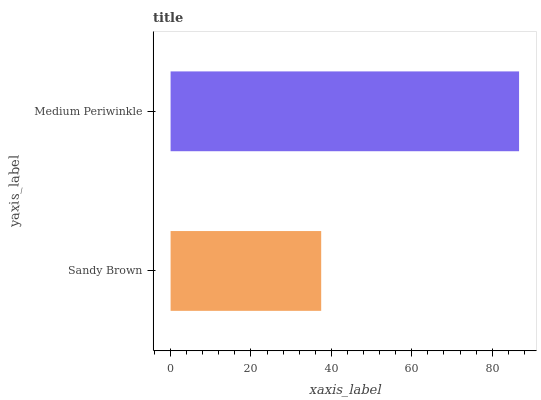Is Sandy Brown the minimum?
Answer yes or no. Yes. Is Medium Periwinkle the maximum?
Answer yes or no. Yes. Is Medium Periwinkle the minimum?
Answer yes or no. No. Is Medium Periwinkle greater than Sandy Brown?
Answer yes or no. Yes. Is Sandy Brown less than Medium Periwinkle?
Answer yes or no. Yes. Is Sandy Brown greater than Medium Periwinkle?
Answer yes or no. No. Is Medium Periwinkle less than Sandy Brown?
Answer yes or no. No. Is Medium Periwinkle the high median?
Answer yes or no. Yes. Is Sandy Brown the low median?
Answer yes or no. Yes. Is Sandy Brown the high median?
Answer yes or no. No. Is Medium Periwinkle the low median?
Answer yes or no. No. 